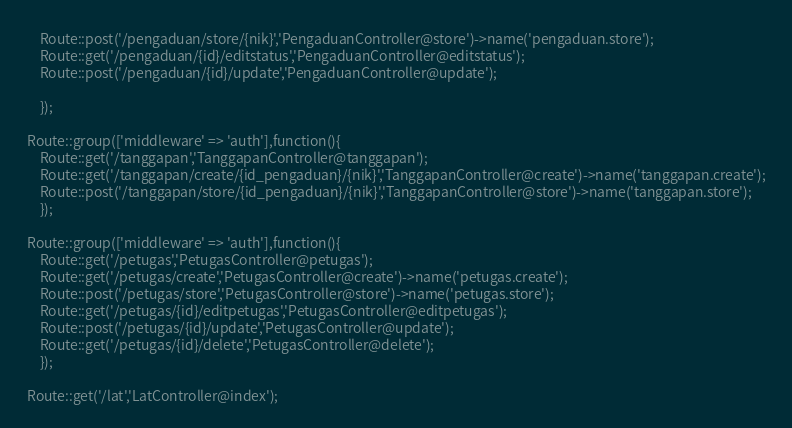<code> <loc_0><loc_0><loc_500><loc_500><_PHP_>    Route::post('/pengaduan/store/{nik}','PengaduanController@store')->name('pengaduan.store');
    Route::get('/pengaduan/{id}/editstatus','PengaduanController@editstatus');
    Route::post('/pengaduan/{id}/update','PengaduanController@update');
    
    }); 

Route::group(['middleware' => 'auth'],function(){
    Route::get('/tanggapan','TanggapanController@tanggapan');
    Route::get('/tanggapan/create/{id_pengaduan}/{nik}','TanggapanController@create')->name('tanggapan.create');
    Route::post('/tanggapan/store/{id_pengaduan}/{nik}','TanggapanController@store')->name('tanggapan.store');
    });   

Route::group(['middleware' => 'auth'],function(){
    Route::get('/petugas','PetugasController@petugas');
    Route::get('/petugas/create','PetugasController@create')->name('petugas.create');
    Route::post('/petugas/store','PetugasController@store')->name('petugas.store');
    Route::get('/petugas/{id}/editpetugas','PetugasController@editpetugas');
    Route::post('/petugas/{id}/update','PetugasController@update');
    Route::get('/petugas/{id}/delete','PetugasController@delete');
    }); 

Route::get('/lat','LatController@index');</code> 